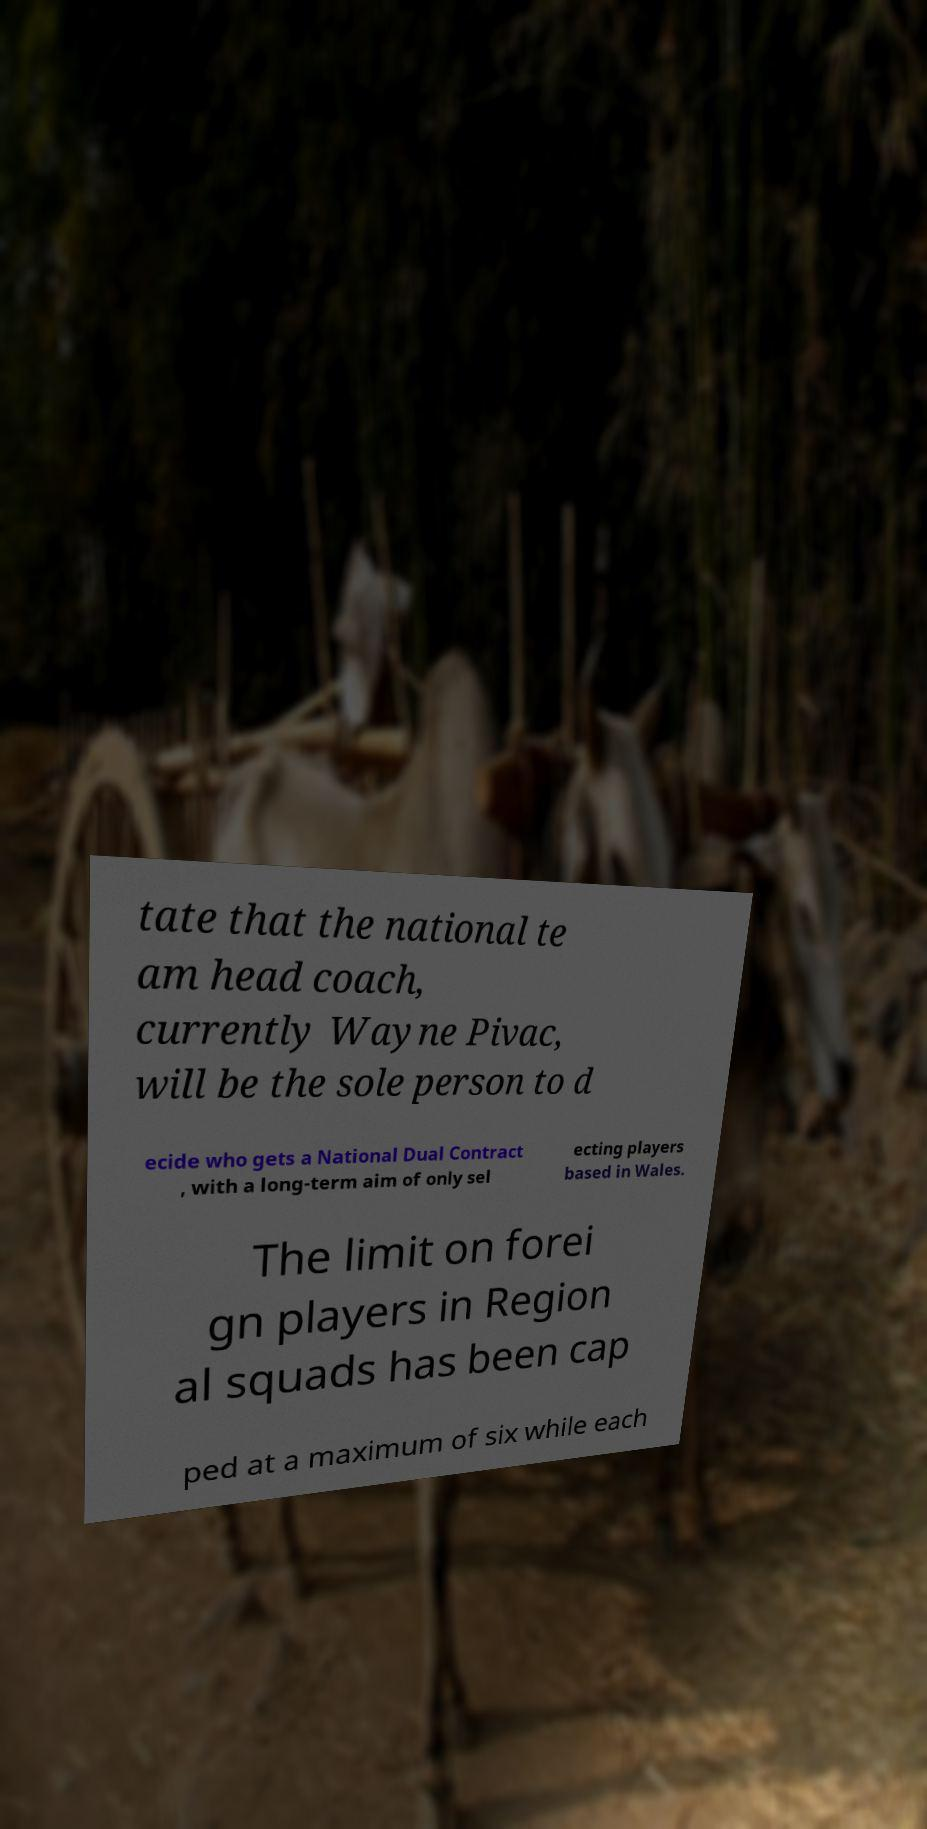Could you assist in decoding the text presented in this image and type it out clearly? tate that the national te am head coach, currently Wayne Pivac, will be the sole person to d ecide who gets a National Dual Contract , with a long-term aim of only sel ecting players based in Wales. The limit on forei gn players in Region al squads has been cap ped at a maximum of six while each 